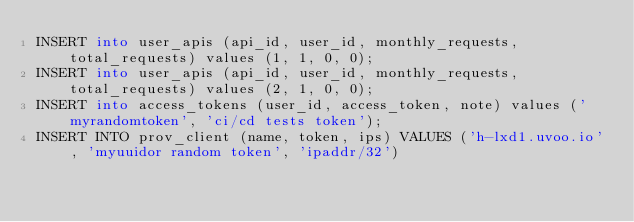<code> <loc_0><loc_0><loc_500><loc_500><_SQL_>INSERT into user_apis (api_id, user_id, monthly_requests, total_requests) values (1, 1, 0, 0);
INSERT into user_apis (api_id, user_id, monthly_requests, total_requests) values (2, 1, 0, 0);
INSERT into access_tokens (user_id, access_token, note) values ('myrandomtoken', 'ci/cd tests token');
INSERT INTO prov_client (name, token, ips) VALUES ('h-lxd1.uvoo.io', 'myuuidor random token', 'ipaddr/32')
</code> 